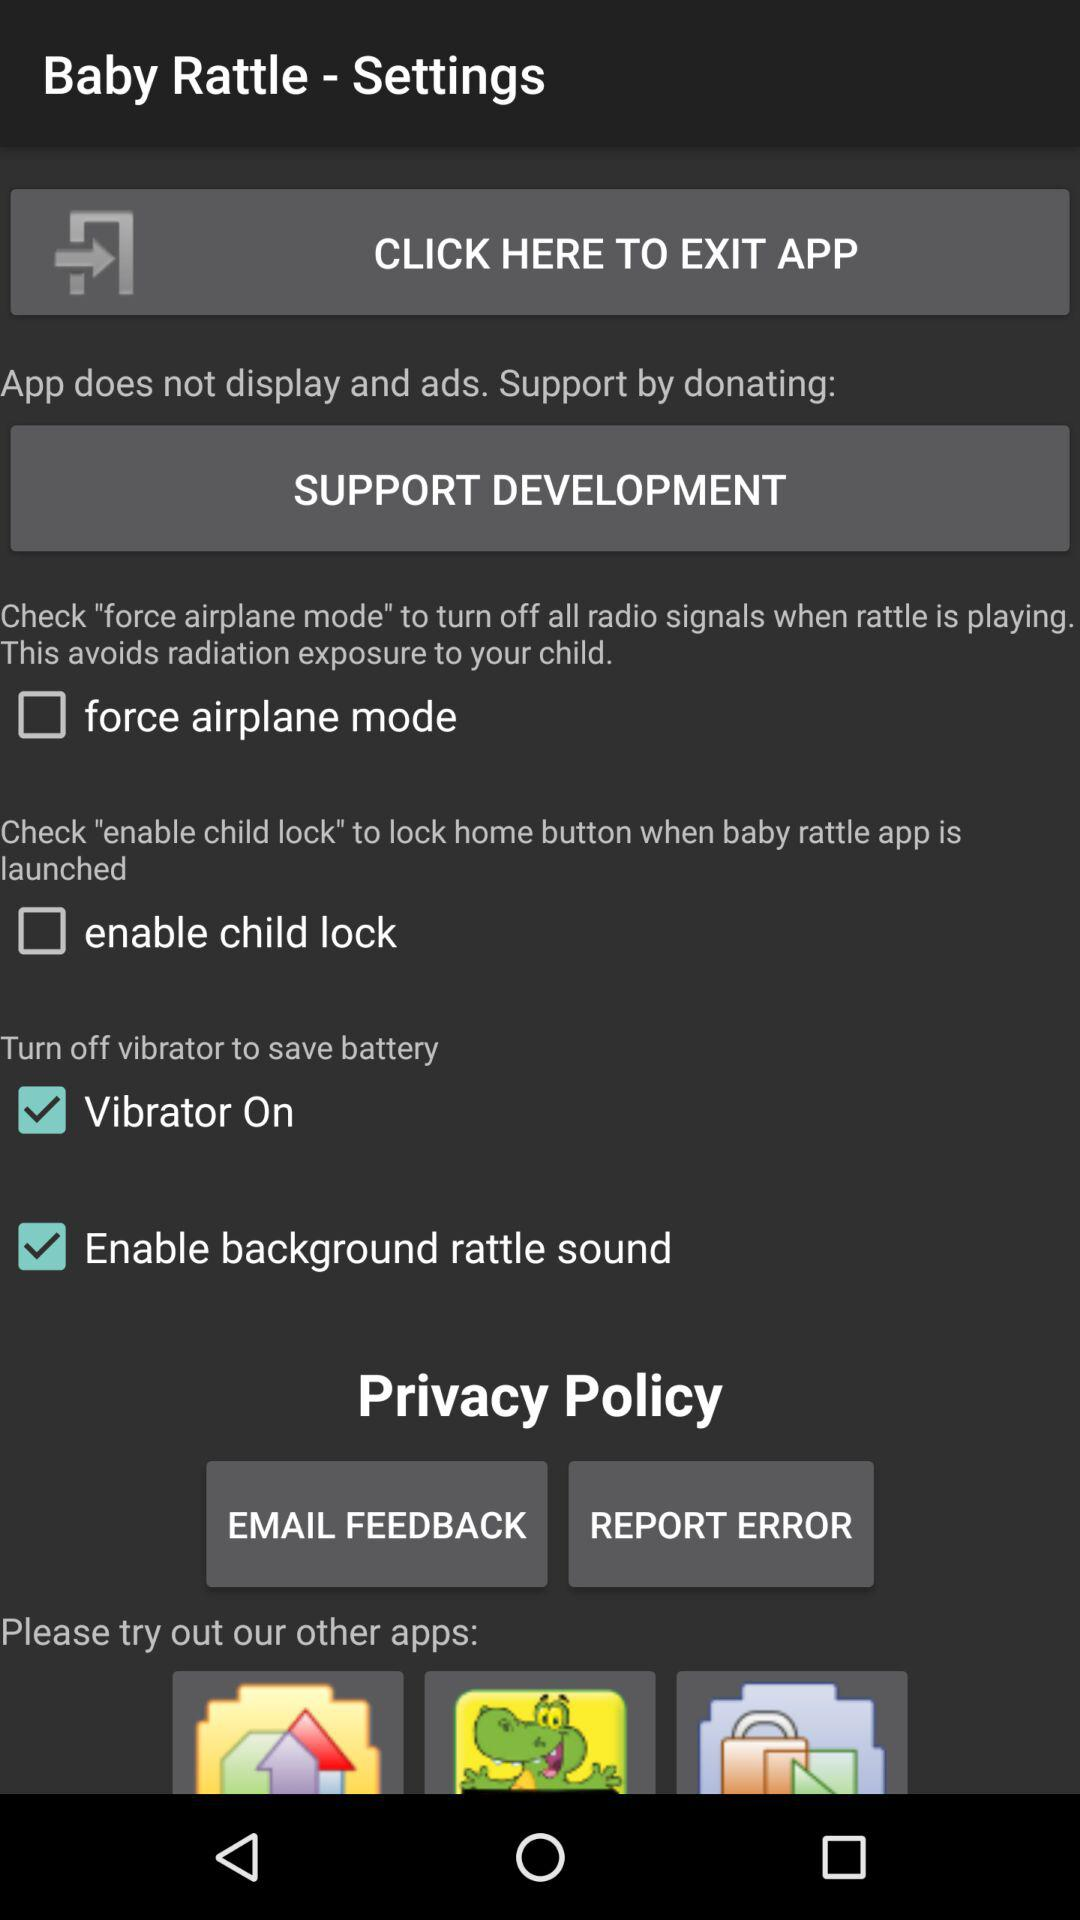Which checkbox is selected? The selected checkboxes are "Vibrator On" and "Enable background rattle sound". 